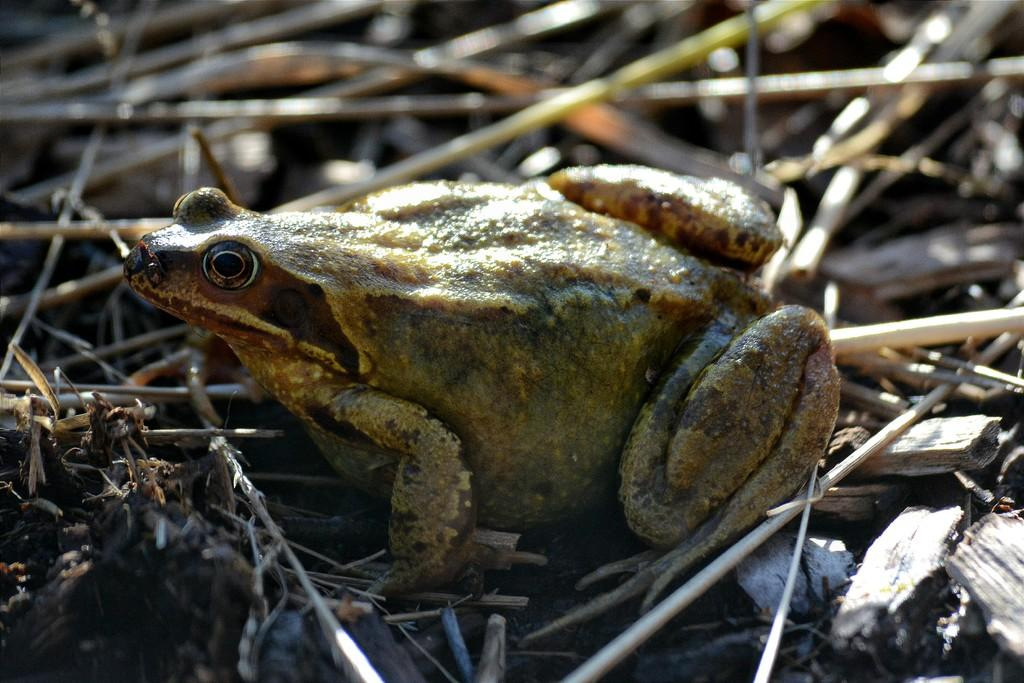What animal is present in the image? There is a frog in the image. How is the frog positioned in the image? The frog is on sticks. Can you describe the background of the image? The background of the image is blurred. What is the opinion of the spy about the frog in the image? There is no indication of a spy or any opinions in the image; it simply features a frog on sticks with a blurred background. 